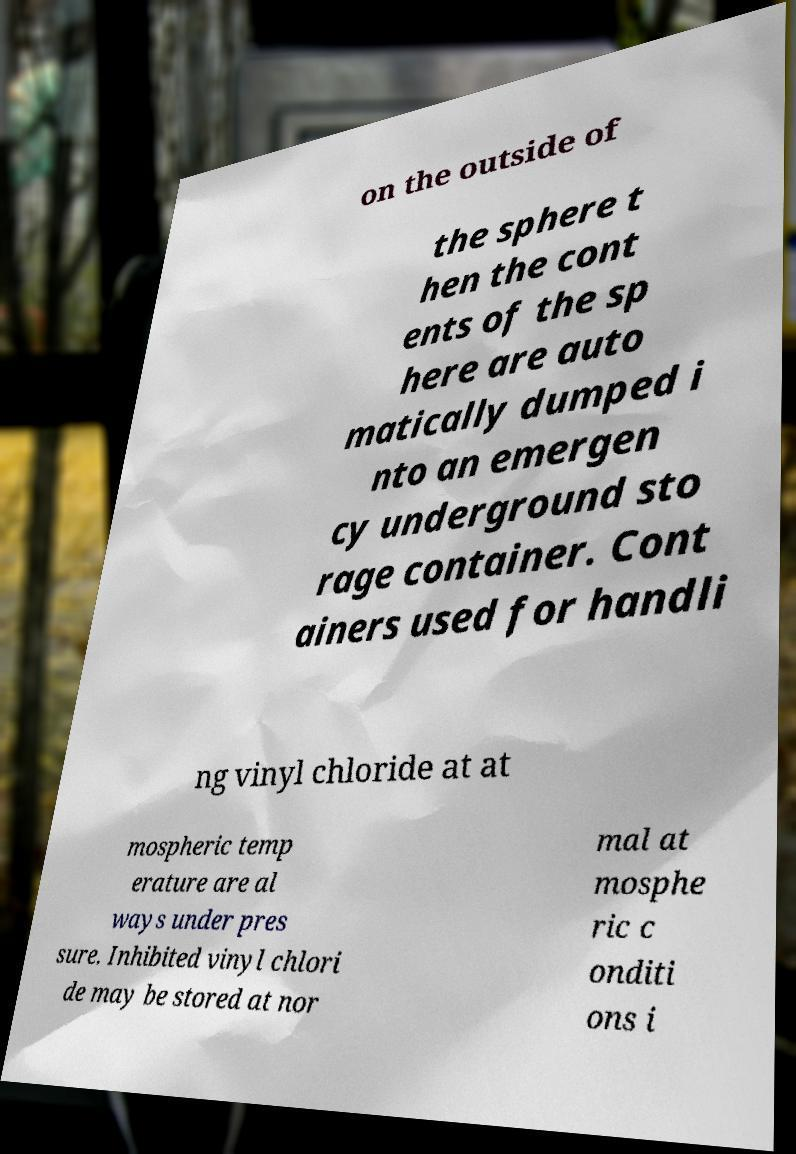Could you assist in decoding the text presented in this image and type it out clearly? on the outside of the sphere t hen the cont ents of the sp here are auto matically dumped i nto an emergen cy underground sto rage container. Cont ainers used for handli ng vinyl chloride at at mospheric temp erature are al ways under pres sure. Inhibited vinyl chlori de may be stored at nor mal at mosphe ric c onditi ons i 